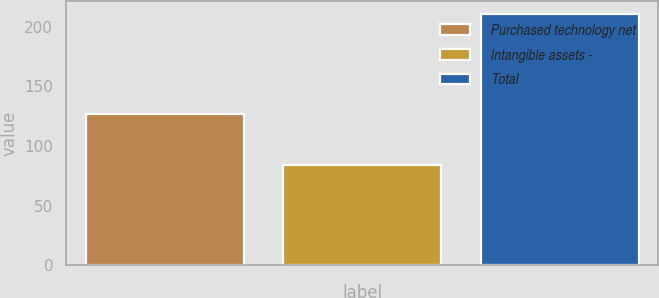Convert chart to OTSL. <chart><loc_0><loc_0><loc_500><loc_500><bar_chart><fcel>Purchased technology net<fcel>Intangible assets -<fcel>Total<nl><fcel>127<fcel>84<fcel>211<nl></chart> 